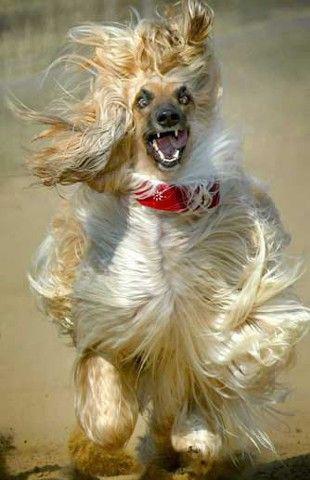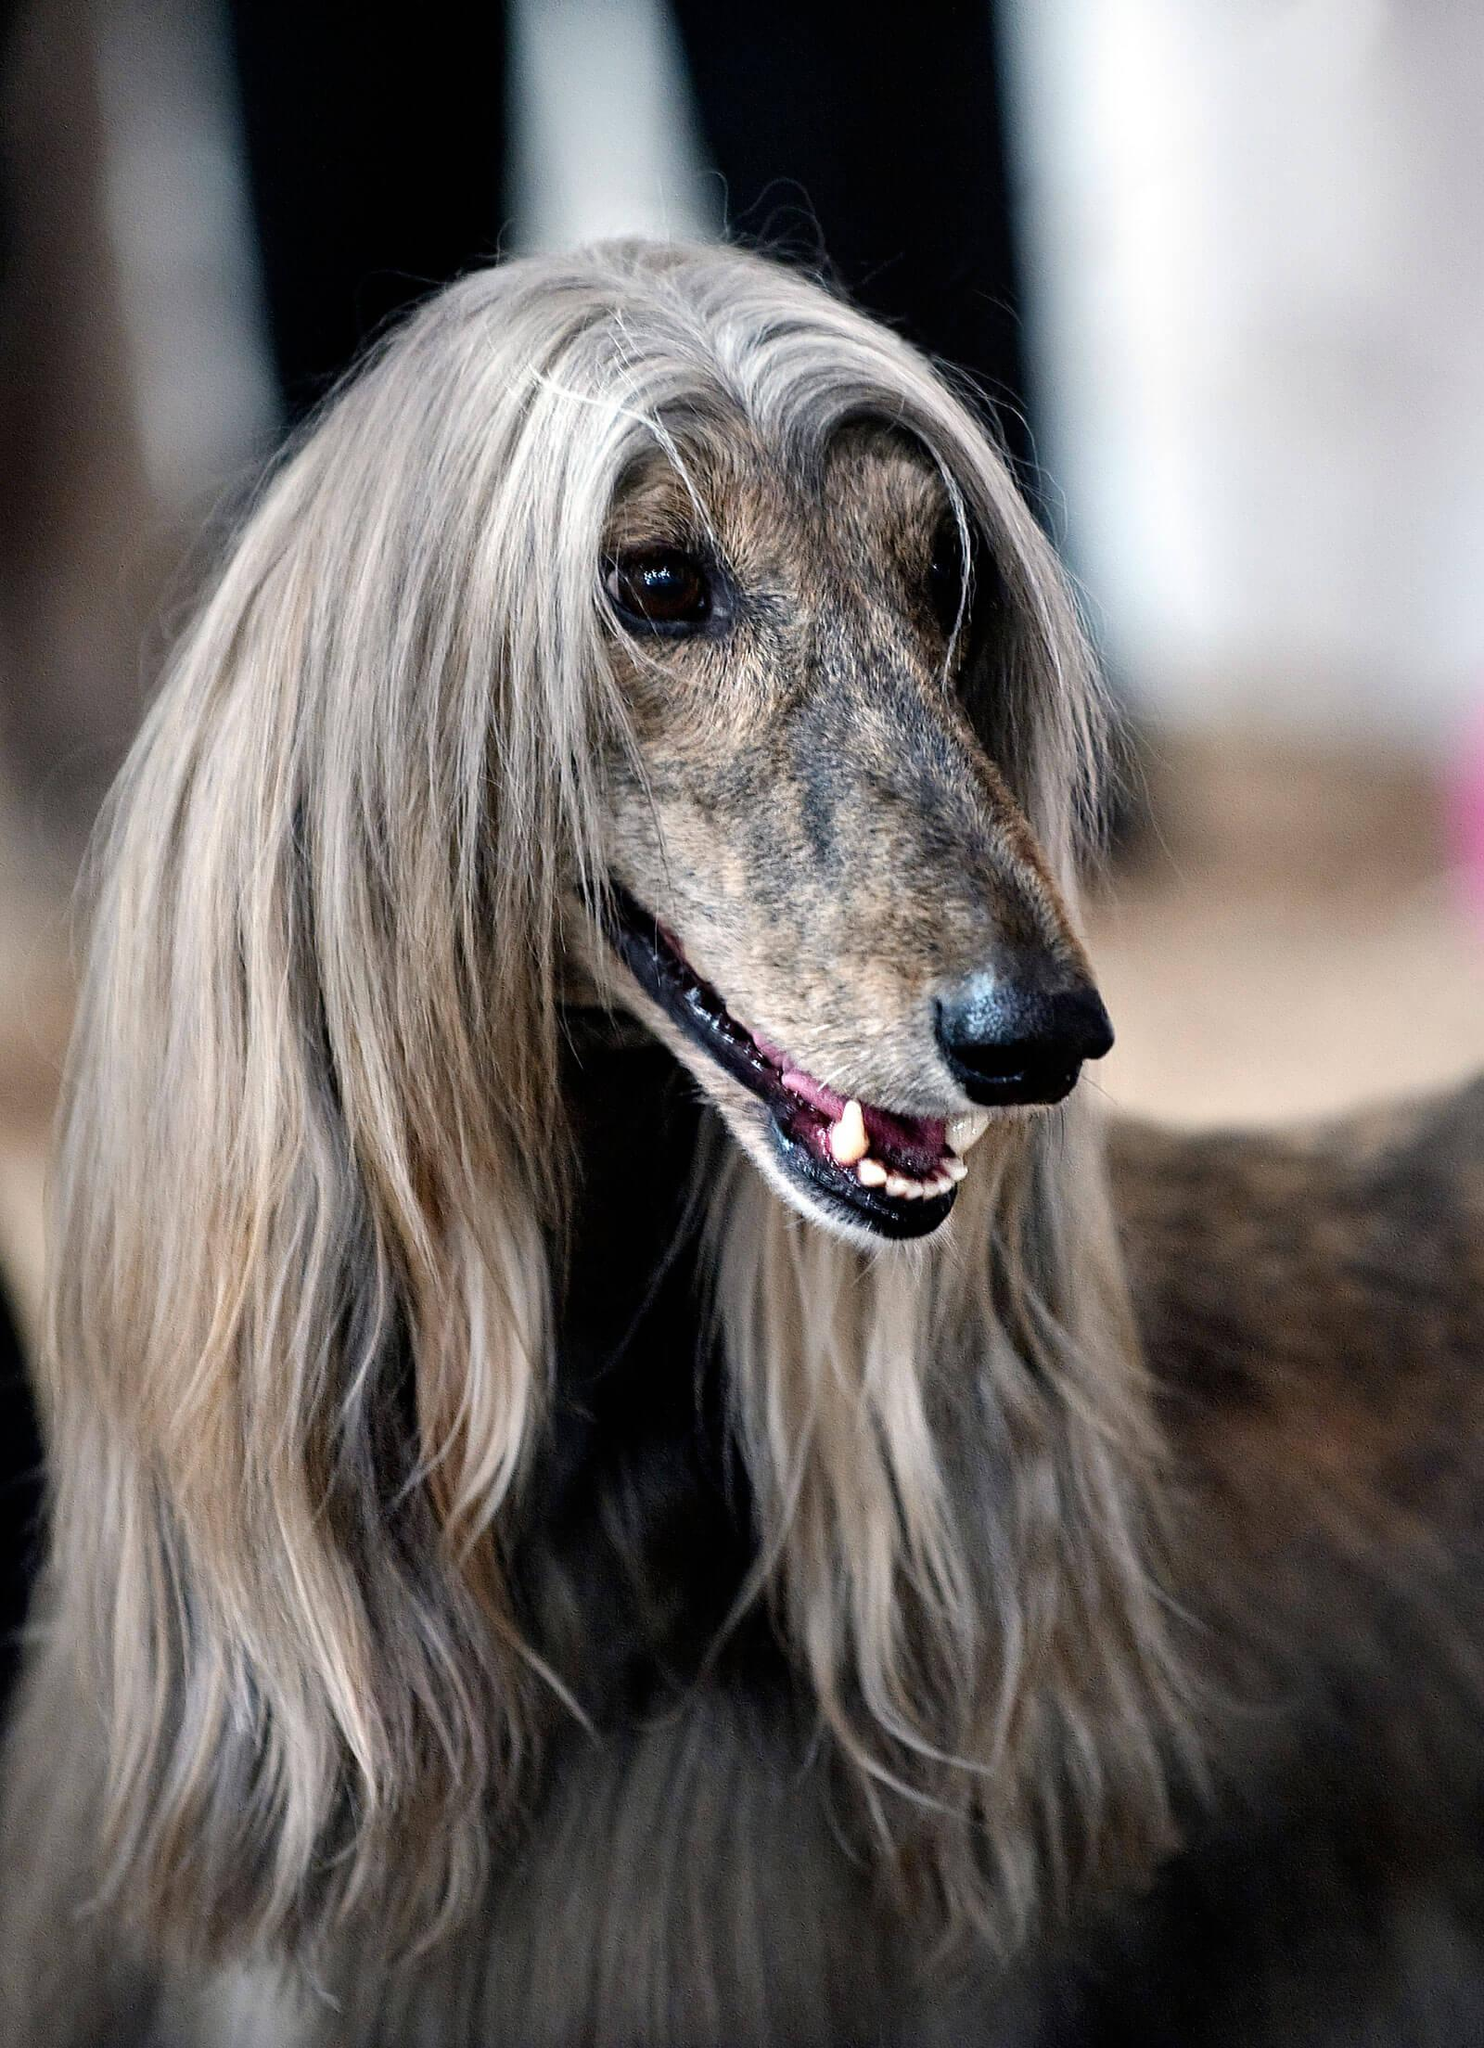The first image is the image on the left, the second image is the image on the right. Examine the images to the left and right. Is the description "In one image, one or more dogs with a long snout and black nose is wearing a head covering that extends down the neck, while a single dog in the second image is bareheaded." accurate? Answer yes or no. No. The first image is the image on the left, the second image is the image on the right. Evaluate the accuracy of this statement regarding the images: "An image includes a dog wearing something that covers its neck and the top of its head.". Is it true? Answer yes or no. No. 